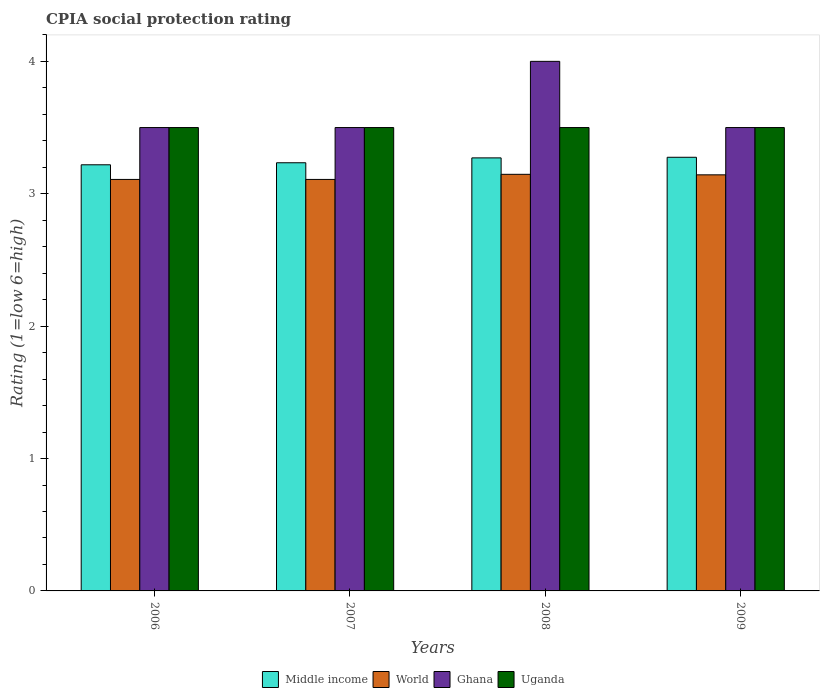How many different coloured bars are there?
Give a very brief answer. 4. Are the number of bars on each tick of the X-axis equal?
Your answer should be very brief. Yes. How many bars are there on the 3rd tick from the left?
Provide a short and direct response. 4. What is the label of the 1st group of bars from the left?
Ensure brevity in your answer.  2006. What is the CPIA rating in Uganda in 2009?
Give a very brief answer. 3.5. Across all years, what is the maximum CPIA rating in Middle income?
Ensure brevity in your answer.  3.28. Across all years, what is the minimum CPIA rating in Uganda?
Provide a succinct answer. 3.5. In which year was the CPIA rating in Ghana maximum?
Your answer should be very brief. 2008. What is the total CPIA rating in World in the graph?
Your response must be concise. 12.51. What is the difference between the CPIA rating in Middle income in 2006 and that in 2009?
Provide a succinct answer. -0.06. What is the difference between the CPIA rating in World in 2008 and the CPIA rating in Middle income in 2006?
Give a very brief answer. -0.07. What is the average CPIA rating in World per year?
Your answer should be very brief. 3.13. Is the CPIA rating in Uganda in 2006 less than that in 2008?
Offer a very short reply. No. Is the difference between the CPIA rating in Uganda in 2007 and 2009 greater than the difference between the CPIA rating in Ghana in 2007 and 2009?
Offer a terse response. No. What is the difference between the highest and the second highest CPIA rating in World?
Keep it short and to the point. 0. What is the difference between the highest and the lowest CPIA rating in Middle income?
Offer a very short reply. 0.06. Is it the case that in every year, the sum of the CPIA rating in World and CPIA rating in Uganda is greater than the sum of CPIA rating in Ghana and CPIA rating in Middle income?
Ensure brevity in your answer.  No. Is it the case that in every year, the sum of the CPIA rating in Uganda and CPIA rating in Middle income is greater than the CPIA rating in Ghana?
Your answer should be very brief. Yes. How many bars are there?
Offer a terse response. 16. How many years are there in the graph?
Offer a terse response. 4. Where does the legend appear in the graph?
Offer a terse response. Bottom center. How many legend labels are there?
Keep it short and to the point. 4. How are the legend labels stacked?
Your response must be concise. Horizontal. What is the title of the graph?
Your response must be concise. CPIA social protection rating. Does "Germany" appear as one of the legend labels in the graph?
Ensure brevity in your answer.  No. What is the Rating (1=low 6=high) in Middle income in 2006?
Provide a short and direct response. 3.22. What is the Rating (1=low 6=high) in World in 2006?
Ensure brevity in your answer.  3.11. What is the Rating (1=low 6=high) of Ghana in 2006?
Your answer should be very brief. 3.5. What is the Rating (1=low 6=high) of Middle income in 2007?
Offer a very short reply. 3.23. What is the Rating (1=low 6=high) in World in 2007?
Provide a succinct answer. 3.11. What is the Rating (1=low 6=high) in Uganda in 2007?
Offer a very short reply. 3.5. What is the Rating (1=low 6=high) of Middle income in 2008?
Your answer should be very brief. 3.27. What is the Rating (1=low 6=high) of World in 2008?
Ensure brevity in your answer.  3.15. What is the Rating (1=low 6=high) in Ghana in 2008?
Your answer should be compact. 4. What is the Rating (1=low 6=high) in Middle income in 2009?
Your answer should be compact. 3.28. What is the Rating (1=low 6=high) in World in 2009?
Give a very brief answer. 3.14. Across all years, what is the maximum Rating (1=low 6=high) of Middle income?
Give a very brief answer. 3.28. Across all years, what is the maximum Rating (1=low 6=high) in World?
Your response must be concise. 3.15. Across all years, what is the maximum Rating (1=low 6=high) of Uganda?
Provide a succinct answer. 3.5. Across all years, what is the minimum Rating (1=low 6=high) in Middle income?
Give a very brief answer. 3.22. Across all years, what is the minimum Rating (1=low 6=high) in World?
Your answer should be compact. 3.11. What is the total Rating (1=low 6=high) in Middle income in the graph?
Provide a succinct answer. 13. What is the total Rating (1=low 6=high) in World in the graph?
Offer a terse response. 12.51. What is the total Rating (1=low 6=high) in Ghana in the graph?
Your answer should be compact. 14.5. What is the total Rating (1=low 6=high) in Uganda in the graph?
Offer a terse response. 14. What is the difference between the Rating (1=low 6=high) in Middle income in 2006 and that in 2007?
Ensure brevity in your answer.  -0.02. What is the difference between the Rating (1=low 6=high) of World in 2006 and that in 2007?
Your answer should be compact. 0. What is the difference between the Rating (1=low 6=high) in Ghana in 2006 and that in 2007?
Ensure brevity in your answer.  0. What is the difference between the Rating (1=low 6=high) in Middle income in 2006 and that in 2008?
Make the answer very short. -0.05. What is the difference between the Rating (1=low 6=high) of World in 2006 and that in 2008?
Your answer should be very brief. -0.04. What is the difference between the Rating (1=low 6=high) of Ghana in 2006 and that in 2008?
Your response must be concise. -0.5. What is the difference between the Rating (1=low 6=high) of Middle income in 2006 and that in 2009?
Your answer should be very brief. -0.06. What is the difference between the Rating (1=low 6=high) of World in 2006 and that in 2009?
Ensure brevity in your answer.  -0.03. What is the difference between the Rating (1=low 6=high) in Ghana in 2006 and that in 2009?
Make the answer very short. 0. What is the difference between the Rating (1=low 6=high) in Uganda in 2006 and that in 2009?
Keep it short and to the point. 0. What is the difference between the Rating (1=low 6=high) of Middle income in 2007 and that in 2008?
Your answer should be compact. -0.04. What is the difference between the Rating (1=low 6=high) in World in 2007 and that in 2008?
Provide a short and direct response. -0.04. What is the difference between the Rating (1=low 6=high) of Ghana in 2007 and that in 2008?
Provide a short and direct response. -0.5. What is the difference between the Rating (1=low 6=high) in Uganda in 2007 and that in 2008?
Your response must be concise. 0. What is the difference between the Rating (1=low 6=high) in Middle income in 2007 and that in 2009?
Provide a short and direct response. -0.04. What is the difference between the Rating (1=low 6=high) of World in 2007 and that in 2009?
Make the answer very short. -0.03. What is the difference between the Rating (1=low 6=high) of Ghana in 2007 and that in 2009?
Keep it short and to the point. 0. What is the difference between the Rating (1=low 6=high) of Middle income in 2008 and that in 2009?
Your answer should be very brief. -0. What is the difference between the Rating (1=low 6=high) of World in 2008 and that in 2009?
Keep it short and to the point. 0. What is the difference between the Rating (1=low 6=high) in Ghana in 2008 and that in 2009?
Provide a succinct answer. 0.5. What is the difference between the Rating (1=low 6=high) in Middle income in 2006 and the Rating (1=low 6=high) in World in 2007?
Keep it short and to the point. 0.11. What is the difference between the Rating (1=low 6=high) of Middle income in 2006 and the Rating (1=low 6=high) of Ghana in 2007?
Provide a succinct answer. -0.28. What is the difference between the Rating (1=low 6=high) of Middle income in 2006 and the Rating (1=low 6=high) of Uganda in 2007?
Provide a succinct answer. -0.28. What is the difference between the Rating (1=low 6=high) of World in 2006 and the Rating (1=low 6=high) of Ghana in 2007?
Your response must be concise. -0.39. What is the difference between the Rating (1=low 6=high) in World in 2006 and the Rating (1=low 6=high) in Uganda in 2007?
Give a very brief answer. -0.39. What is the difference between the Rating (1=low 6=high) of Middle income in 2006 and the Rating (1=low 6=high) of World in 2008?
Provide a succinct answer. 0.07. What is the difference between the Rating (1=low 6=high) in Middle income in 2006 and the Rating (1=low 6=high) in Ghana in 2008?
Offer a terse response. -0.78. What is the difference between the Rating (1=low 6=high) in Middle income in 2006 and the Rating (1=low 6=high) in Uganda in 2008?
Provide a short and direct response. -0.28. What is the difference between the Rating (1=low 6=high) of World in 2006 and the Rating (1=low 6=high) of Ghana in 2008?
Offer a very short reply. -0.89. What is the difference between the Rating (1=low 6=high) of World in 2006 and the Rating (1=low 6=high) of Uganda in 2008?
Provide a succinct answer. -0.39. What is the difference between the Rating (1=low 6=high) in Middle income in 2006 and the Rating (1=low 6=high) in World in 2009?
Your answer should be compact. 0.08. What is the difference between the Rating (1=low 6=high) of Middle income in 2006 and the Rating (1=low 6=high) of Ghana in 2009?
Provide a short and direct response. -0.28. What is the difference between the Rating (1=low 6=high) of Middle income in 2006 and the Rating (1=low 6=high) of Uganda in 2009?
Provide a short and direct response. -0.28. What is the difference between the Rating (1=low 6=high) of World in 2006 and the Rating (1=low 6=high) of Ghana in 2009?
Offer a very short reply. -0.39. What is the difference between the Rating (1=low 6=high) in World in 2006 and the Rating (1=low 6=high) in Uganda in 2009?
Provide a succinct answer. -0.39. What is the difference between the Rating (1=low 6=high) of Middle income in 2007 and the Rating (1=low 6=high) of World in 2008?
Your answer should be very brief. 0.09. What is the difference between the Rating (1=low 6=high) of Middle income in 2007 and the Rating (1=low 6=high) of Ghana in 2008?
Provide a succinct answer. -0.77. What is the difference between the Rating (1=low 6=high) in Middle income in 2007 and the Rating (1=low 6=high) in Uganda in 2008?
Keep it short and to the point. -0.27. What is the difference between the Rating (1=low 6=high) in World in 2007 and the Rating (1=low 6=high) in Ghana in 2008?
Provide a succinct answer. -0.89. What is the difference between the Rating (1=low 6=high) in World in 2007 and the Rating (1=low 6=high) in Uganda in 2008?
Your answer should be compact. -0.39. What is the difference between the Rating (1=low 6=high) in Ghana in 2007 and the Rating (1=low 6=high) in Uganda in 2008?
Make the answer very short. 0. What is the difference between the Rating (1=low 6=high) in Middle income in 2007 and the Rating (1=low 6=high) in World in 2009?
Your answer should be compact. 0.09. What is the difference between the Rating (1=low 6=high) of Middle income in 2007 and the Rating (1=low 6=high) of Ghana in 2009?
Your response must be concise. -0.27. What is the difference between the Rating (1=low 6=high) in Middle income in 2007 and the Rating (1=low 6=high) in Uganda in 2009?
Give a very brief answer. -0.27. What is the difference between the Rating (1=low 6=high) of World in 2007 and the Rating (1=low 6=high) of Ghana in 2009?
Your response must be concise. -0.39. What is the difference between the Rating (1=low 6=high) of World in 2007 and the Rating (1=low 6=high) of Uganda in 2009?
Ensure brevity in your answer.  -0.39. What is the difference between the Rating (1=low 6=high) of Ghana in 2007 and the Rating (1=low 6=high) of Uganda in 2009?
Provide a short and direct response. 0. What is the difference between the Rating (1=low 6=high) in Middle income in 2008 and the Rating (1=low 6=high) in World in 2009?
Keep it short and to the point. 0.13. What is the difference between the Rating (1=low 6=high) of Middle income in 2008 and the Rating (1=low 6=high) of Ghana in 2009?
Ensure brevity in your answer.  -0.23. What is the difference between the Rating (1=low 6=high) of Middle income in 2008 and the Rating (1=low 6=high) of Uganda in 2009?
Provide a succinct answer. -0.23. What is the difference between the Rating (1=low 6=high) of World in 2008 and the Rating (1=low 6=high) of Ghana in 2009?
Offer a terse response. -0.35. What is the difference between the Rating (1=low 6=high) of World in 2008 and the Rating (1=low 6=high) of Uganda in 2009?
Offer a terse response. -0.35. What is the average Rating (1=low 6=high) in Middle income per year?
Give a very brief answer. 3.25. What is the average Rating (1=low 6=high) in World per year?
Make the answer very short. 3.13. What is the average Rating (1=low 6=high) in Ghana per year?
Give a very brief answer. 3.62. What is the average Rating (1=low 6=high) of Uganda per year?
Offer a terse response. 3.5. In the year 2006, what is the difference between the Rating (1=low 6=high) in Middle income and Rating (1=low 6=high) in World?
Ensure brevity in your answer.  0.11. In the year 2006, what is the difference between the Rating (1=low 6=high) in Middle income and Rating (1=low 6=high) in Ghana?
Your answer should be compact. -0.28. In the year 2006, what is the difference between the Rating (1=low 6=high) of Middle income and Rating (1=low 6=high) of Uganda?
Your answer should be compact. -0.28. In the year 2006, what is the difference between the Rating (1=low 6=high) of World and Rating (1=low 6=high) of Ghana?
Offer a terse response. -0.39. In the year 2006, what is the difference between the Rating (1=low 6=high) in World and Rating (1=low 6=high) in Uganda?
Give a very brief answer. -0.39. In the year 2006, what is the difference between the Rating (1=low 6=high) of Ghana and Rating (1=low 6=high) of Uganda?
Offer a very short reply. 0. In the year 2007, what is the difference between the Rating (1=low 6=high) in Middle income and Rating (1=low 6=high) in World?
Your answer should be very brief. 0.13. In the year 2007, what is the difference between the Rating (1=low 6=high) in Middle income and Rating (1=low 6=high) in Ghana?
Your answer should be compact. -0.27. In the year 2007, what is the difference between the Rating (1=low 6=high) in Middle income and Rating (1=low 6=high) in Uganda?
Your answer should be compact. -0.27. In the year 2007, what is the difference between the Rating (1=low 6=high) in World and Rating (1=low 6=high) in Ghana?
Make the answer very short. -0.39. In the year 2007, what is the difference between the Rating (1=low 6=high) in World and Rating (1=low 6=high) in Uganda?
Your response must be concise. -0.39. In the year 2008, what is the difference between the Rating (1=low 6=high) in Middle income and Rating (1=low 6=high) in World?
Provide a succinct answer. 0.12. In the year 2008, what is the difference between the Rating (1=low 6=high) of Middle income and Rating (1=low 6=high) of Ghana?
Offer a very short reply. -0.73. In the year 2008, what is the difference between the Rating (1=low 6=high) of Middle income and Rating (1=low 6=high) of Uganda?
Offer a terse response. -0.23. In the year 2008, what is the difference between the Rating (1=low 6=high) in World and Rating (1=low 6=high) in Ghana?
Give a very brief answer. -0.85. In the year 2008, what is the difference between the Rating (1=low 6=high) of World and Rating (1=low 6=high) of Uganda?
Your answer should be compact. -0.35. In the year 2008, what is the difference between the Rating (1=low 6=high) of Ghana and Rating (1=low 6=high) of Uganda?
Give a very brief answer. 0.5. In the year 2009, what is the difference between the Rating (1=low 6=high) in Middle income and Rating (1=low 6=high) in World?
Your answer should be very brief. 0.13. In the year 2009, what is the difference between the Rating (1=low 6=high) of Middle income and Rating (1=low 6=high) of Ghana?
Offer a terse response. -0.22. In the year 2009, what is the difference between the Rating (1=low 6=high) in Middle income and Rating (1=low 6=high) in Uganda?
Your answer should be compact. -0.22. In the year 2009, what is the difference between the Rating (1=low 6=high) of World and Rating (1=low 6=high) of Ghana?
Your answer should be very brief. -0.36. In the year 2009, what is the difference between the Rating (1=low 6=high) of World and Rating (1=low 6=high) of Uganda?
Provide a succinct answer. -0.36. What is the ratio of the Rating (1=low 6=high) of Middle income in 2006 to that in 2007?
Your response must be concise. 1. What is the ratio of the Rating (1=low 6=high) of World in 2006 to that in 2007?
Provide a short and direct response. 1. What is the ratio of the Rating (1=low 6=high) of Ghana in 2006 to that in 2007?
Your answer should be very brief. 1. What is the ratio of the Rating (1=low 6=high) of Uganda in 2006 to that in 2007?
Make the answer very short. 1. What is the ratio of the Rating (1=low 6=high) of Middle income in 2006 to that in 2008?
Provide a succinct answer. 0.98. What is the ratio of the Rating (1=low 6=high) of World in 2006 to that in 2008?
Your response must be concise. 0.99. What is the ratio of the Rating (1=low 6=high) of Ghana in 2006 to that in 2008?
Provide a succinct answer. 0.88. What is the ratio of the Rating (1=low 6=high) in Uganda in 2006 to that in 2008?
Ensure brevity in your answer.  1. What is the ratio of the Rating (1=low 6=high) of Middle income in 2006 to that in 2009?
Keep it short and to the point. 0.98. What is the ratio of the Rating (1=low 6=high) of World in 2006 to that in 2009?
Your response must be concise. 0.99. What is the ratio of the Rating (1=low 6=high) of Uganda in 2006 to that in 2009?
Provide a short and direct response. 1. What is the ratio of the Rating (1=low 6=high) of World in 2007 to that in 2008?
Give a very brief answer. 0.99. What is the ratio of the Rating (1=low 6=high) in Ghana in 2007 to that in 2008?
Keep it short and to the point. 0.88. What is the ratio of the Rating (1=low 6=high) in Middle income in 2007 to that in 2009?
Make the answer very short. 0.99. What is the ratio of the Rating (1=low 6=high) of World in 2007 to that in 2009?
Keep it short and to the point. 0.99. What is the difference between the highest and the second highest Rating (1=low 6=high) of Middle income?
Make the answer very short. 0. What is the difference between the highest and the second highest Rating (1=low 6=high) in World?
Provide a short and direct response. 0. What is the difference between the highest and the lowest Rating (1=low 6=high) of Middle income?
Provide a succinct answer. 0.06. What is the difference between the highest and the lowest Rating (1=low 6=high) of World?
Keep it short and to the point. 0.04. What is the difference between the highest and the lowest Rating (1=low 6=high) in Ghana?
Your answer should be very brief. 0.5. What is the difference between the highest and the lowest Rating (1=low 6=high) in Uganda?
Offer a terse response. 0. 